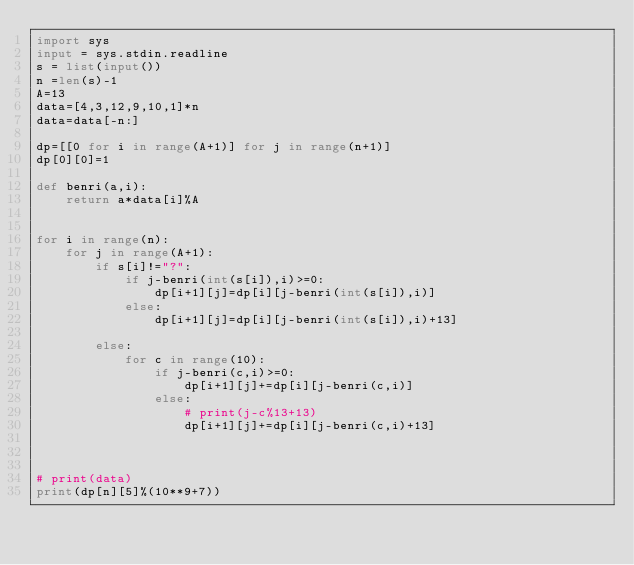Convert code to text. <code><loc_0><loc_0><loc_500><loc_500><_Python_>import sys
input = sys.stdin.readline
s = list(input())
n =len(s)-1
A=13
data=[4,3,12,9,10,1]*n
data=data[-n:]

dp=[[0 for i in range(A+1)] for j in range(n+1)]
dp[0][0]=1

def benri(a,i):
	return a*data[i]%A


for i in range(n):
	for j in range(A+1):
		if s[i]!="?":
			if j-benri(int(s[i]),i)>=0:
				dp[i+1][j]=dp[i][j-benri(int(s[i]),i)]
			else:
				dp[i+1][j]=dp[i][j-benri(int(s[i]),i)+13]

		else:
			for c in range(10):
				if j-benri(c,i)>=0:
					dp[i+1][j]+=dp[i][j-benri(c,i)]
				else:
					# print(j-c%13+13)
					dp[i+1][j]+=dp[i][j-benri(c,i)+13]

			
			
# print(data)
print(dp[n][5]%(10**9+7))
				
</code> 